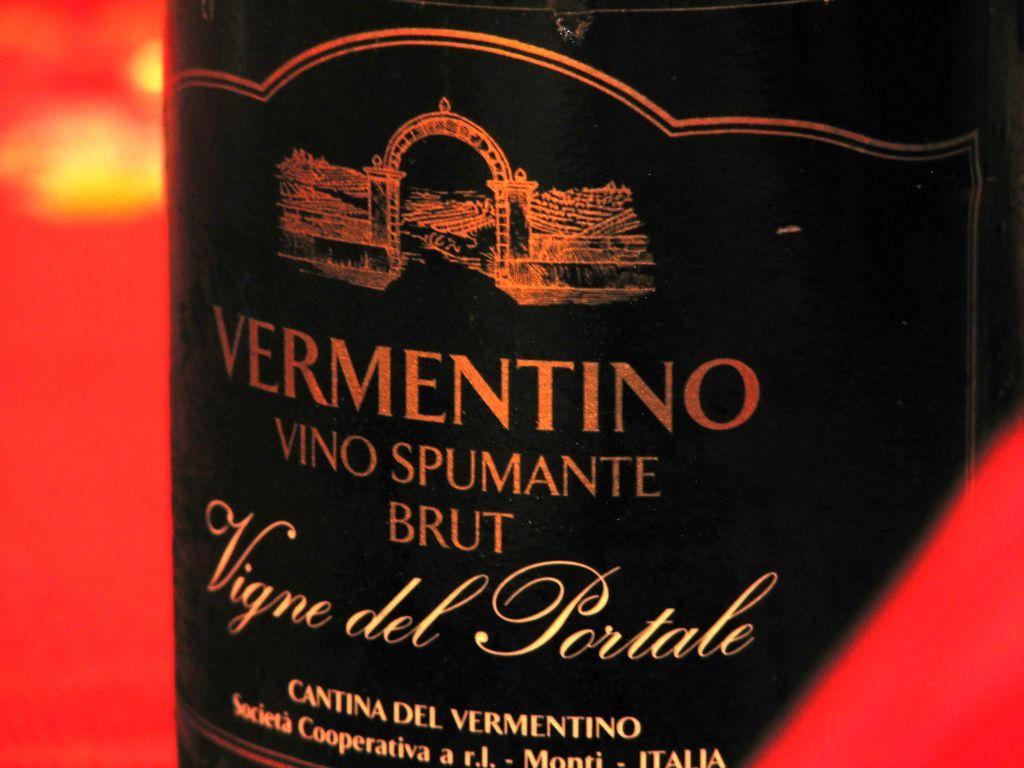What is located in the foreground of the image? There is a bottle in the foreground of the image. Can you describe the objects on the right side of the image? There is a red color object on the right side of the image. What about the objects on the left side of the image? There is also a red color object on the left side of the image. What type of stamp can be seen on the bag in the image? There is no bag or stamp present in the image. 